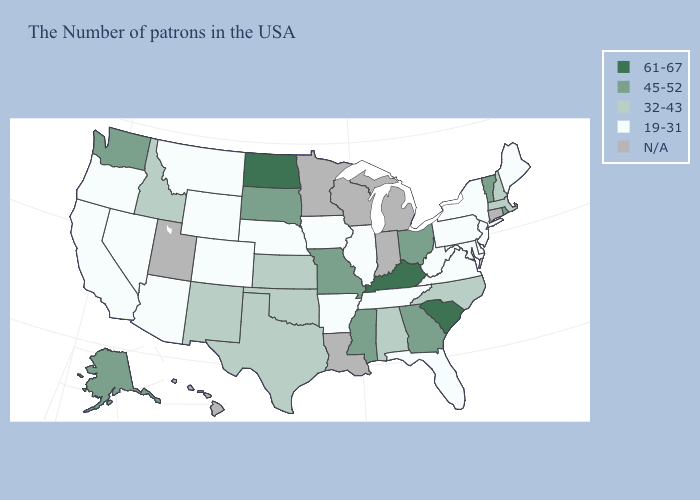Is the legend a continuous bar?
Give a very brief answer. No. Which states have the lowest value in the USA?
Short answer required. Maine, New York, New Jersey, Delaware, Maryland, Pennsylvania, Virginia, West Virginia, Florida, Tennessee, Illinois, Arkansas, Iowa, Nebraska, Wyoming, Colorado, Montana, Arizona, Nevada, California, Oregon. Which states hav the highest value in the Northeast?
Keep it brief. Rhode Island, Vermont. Does the map have missing data?
Be succinct. Yes. Among the states that border Colorado , which have the lowest value?
Concise answer only. Nebraska, Wyoming, Arizona. Does the map have missing data?
Give a very brief answer. Yes. Among the states that border Indiana , which have the highest value?
Give a very brief answer. Kentucky. Name the states that have a value in the range 19-31?
Write a very short answer. Maine, New York, New Jersey, Delaware, Maryland, Pennsylvania, Virginia, West Virginia, Florida, Tennessee, Illinois, Arkansas, Iowa, Nebraska, Wyoming, Colorado, Montana, Arizona, Nevada, California, Oregon. Name the states that have a value in the range 19-31?
Give a very brief answer. Maine, New York, New Jersey, Delaware, Maryland, Pennsylvania, Virginia, West Virginia, Florida, Tennessee, Illinois, Arkansas, Iowa, Nebraska, Wyoming, Colorado, Montana, Arizona, Nevada, California, Oregon. Does the map have missing data?
Quick response, please. Yes. What is the highest value in states that border Georgia?
Answer briefly. 61-67. What is the lowest value in the South?
Be succinct. 19-31. What is the lowest value in states that border Massachusetts?
Quick response, please. 19-31. What is the highest value in states that border Delaware?
Give a very brief answer. 19-31. 